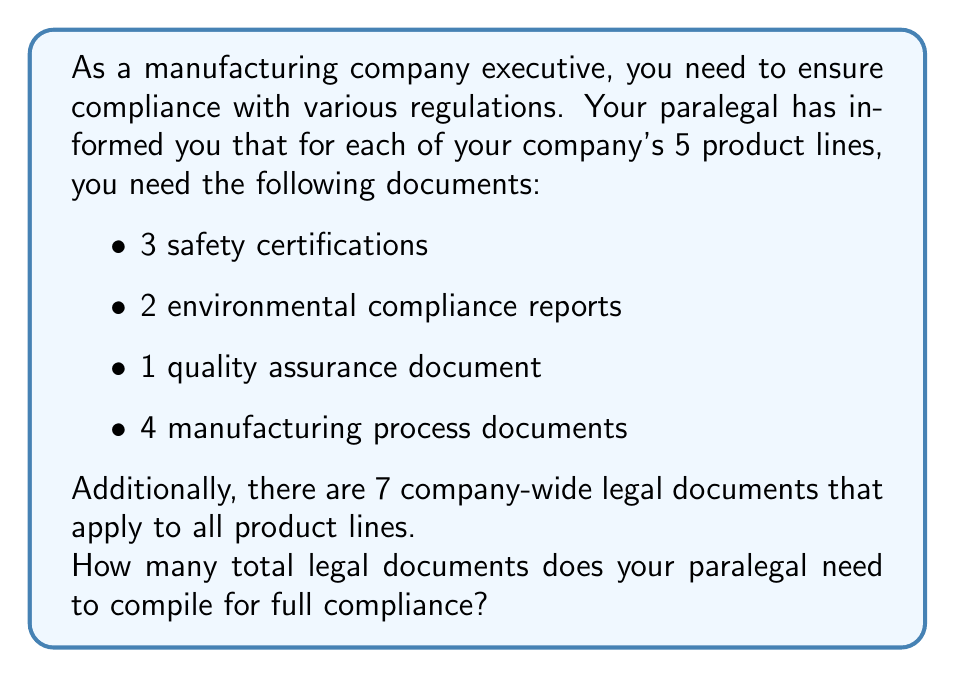Solve this math problem. Let's break this down step-by-step:

1. First, let's calculate the number of documents required per product line:
   $$ \text{Documents per product line} = 3 + 2 + 1 + 4 = 10 $$

2. Now, we need to multiply this by the number of product lines:
   $$ \text{Total product-specific documents} = 10 \times 5 = 50 $$

3. We then add the company-wide documents:
   $$ \text{Total documents} = 50 + 7 = 57 $$

Therefore, the paralegal needs to compile 57 legal documents in total for full compliance.
Answer: 57 documents 